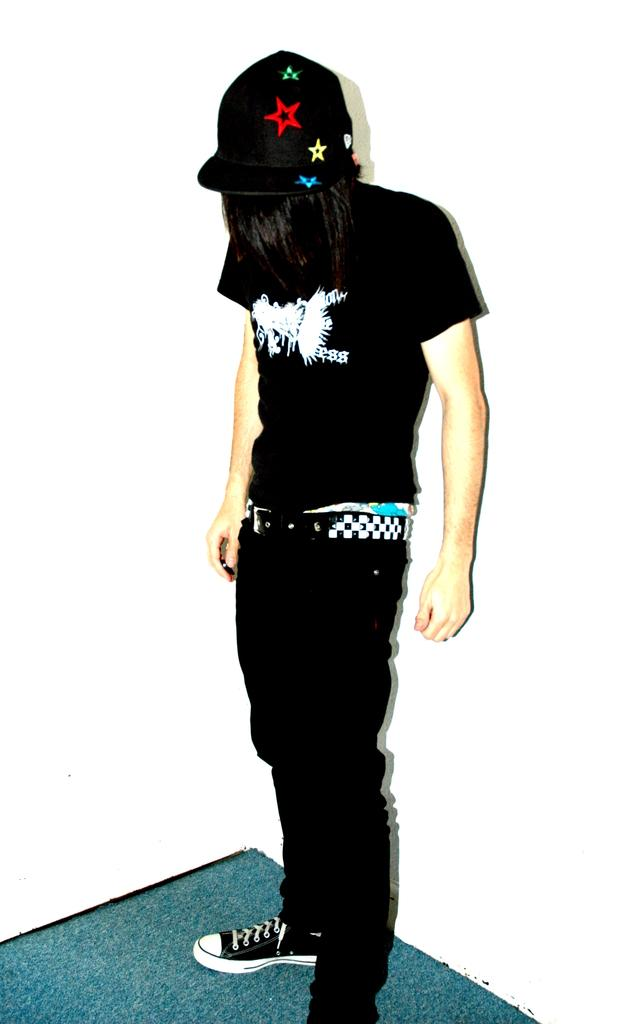Who is present in the image? There is a man in the image. What is the man wearing on his head? The man is wearing a cap. What color is the background of the image? The background of the image is black. What can be seen at the bottom of the image? There is a surface visible at the bottom of the image. What type of rake is the man using in the image? There is no rake present in the image; the man is simply wearing a cap and standing in front of a black background. Can you describe the fight that is taking place in the image? There is no fight depicted in the image; it features a man wearing a cap against a black background. 